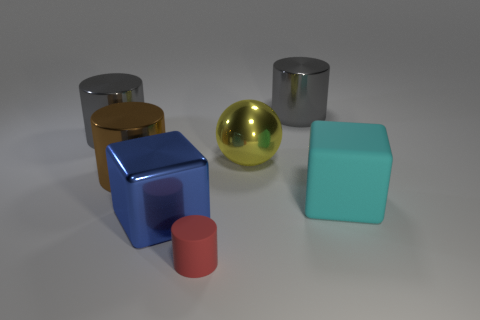How many gray cylinders are the same size as the yellow object?
Make the answer very short. 2. The big thing that is made of the same material as the tiny cylinder is what shape?
Your response must be concise. Cube. Is there a matte thing of the same color as the small matte cylinder?
Your answer should be very brief. No. What is the big cyan object made of?
Your response must be concise. Rubber. What number of things are either red objects or big green metallic things?
Offer a terse response. 1. How big is the rubber thing that is behind the tiny red cylinder?
Your answer should be very brief. Large. What number of other objects are the same material as the yellow sphere?
Offer a very short reply. 4. There is a metal block on the left side of the small rubber cylinder; is there a cylinder to the right of it?
Ensure brevity in your answer.  Yes. Is there any other thing that is the same shape as the large brown metal thing?
Keep it short and to the point. Yes. What color is the rubber thing that is the same shape as the brown shiny thing?
Ensure brevity in your answer.  Red. 